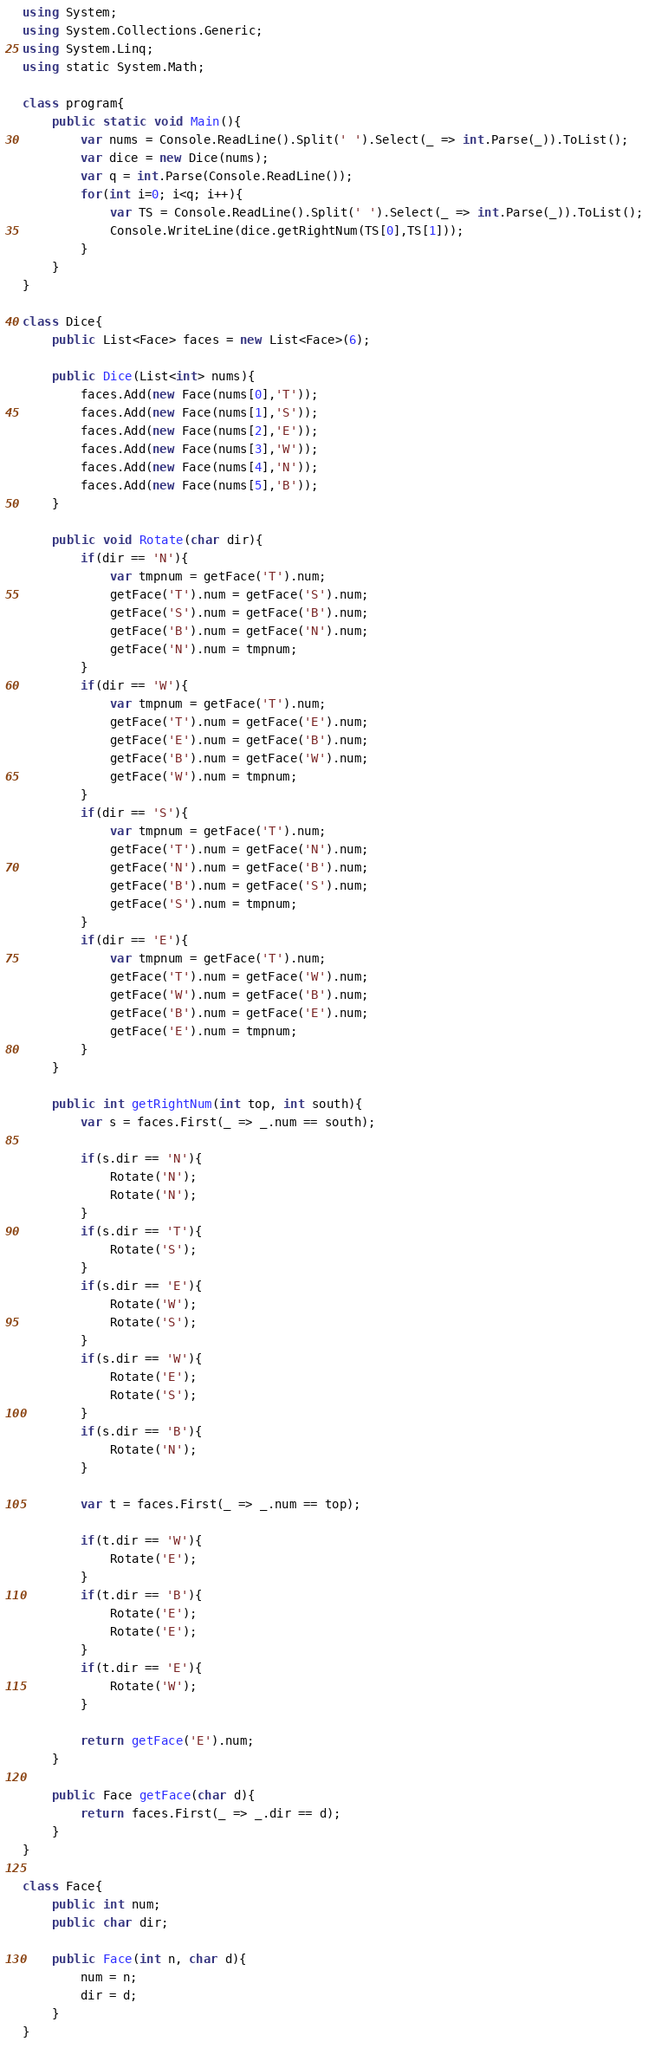<code> <loc_0><loc_0><loc_500><loc_500><_C#_>using System;
using System.Collections.Generic;
using System.Linq;
using static System.Math;

class program{
    public static void Main(){
        var nums = Console.ReadLine().Split(' ').Select(_ => int.Parse(_)).ToList();
        var dice = new Dice(nums);
        var q = int.Parse(Console.ReadLine());
        for(int i=0; i<q; i++){
            var TS = Console.ReadLine().Split(' ').Select(_ => int.Parse(_)).ToList();
            Console.WriteLine(dice.getRightNum(TS[0],TS[1]));
        }
    }
}

class Dice{
    public List<Face> faces = new List<Face>(6);

    public Dice(List<int> nums){
        faces.Add(new Face(nums[0],'T'));
        faces.Add(new Face(nums[1],'S'));
        faces.Add(new Face(nums[2],'E'));
        faces.Add(new Face(nums[3],'W'));
        faces.Add(new Face(nums[4],'N'));
        faces.Add(new Face(nums[5],'B'));
    }

    public void Rotate(char dir){
        if(dir == 'N'){
            var tmpnum = getFace('T').num;
            getFace('T').num = getFace('S').num;
            getFace('S').num = getFace('B').num;
            getFace('B').num = getFace('N').num;
            getFace('N').num = tmpnum;
        }
        if(dir == 'W'){
            var tmpnum = getFace('T').num;
            getFace('T').num = getFace('E').num;
            getFace('E').num = getFace('B').num;
            getFace('B').num = getFace('W').num;
            getFace('W').num = tmpnum;
        }
        if(dir == 'S'){
            var tmpnum = getFace('T').num;
            getFace('T').num = getFace('N').num;
            getFace('N').num = getFace('B').num;
            getFace('B').num = getFace('S').num;
            getFace('S').num = tmpnum;
        }
        if(dir == 'E'){
            var tmpnum = getFace('T').num;
            getFace('T').num = getFace('W').num;
            getFace('W').num = getFace('B').num;
            getFace('B').num = getFace('E').num;
            getFace('E').num = tmpnum;
        }
    }

    public int getRightNum(int top, int south){
        var s = faces.First(_ => _.num == south);

        if(s.dir == 'N'){
            Rotate('N');
            Rotate('N');
        }
        if(s.dir == 'T'){
            Rotate('S');
        }
        if(s.dir == 'E'){
            Rotate('W');
            Rotate('S');
        }
        if(s.dir == 'W'){
            Rotate('E');
            Rotate('S');
        }
        if(s.dir == 'B'){
            Rotate('N');
        }

        var t = faces.First(_ => _.num == top);

        if(t.dir == 'W'){
            Rotate('E');
        }
        if(t.dir == 'B'){
            Rotate('E');
            Rotate('E');
        }
        if(t.dir == 'E'){
            Rotate('W');
        }

        return getFace('E').num;
    }

    public Face getFace(char d){
        return faces.First(_ => _.dir == d);
    }
}

class Face{
    public int num;
    public char dir;

    public Face(int n, char d){
        num = n;
        dir = d;
    }
}

</code> 